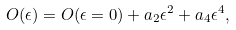Convert formula to latex. <formula><loc_0><loc_0><loc_500><loc_500>O ( \epsilon ) = O ( \epsilon = 0 ) + a _ { 2 } \epsilon ^ { 2 } + a _ { 4 } \epsilon ^ { 4 } ,</formula> 